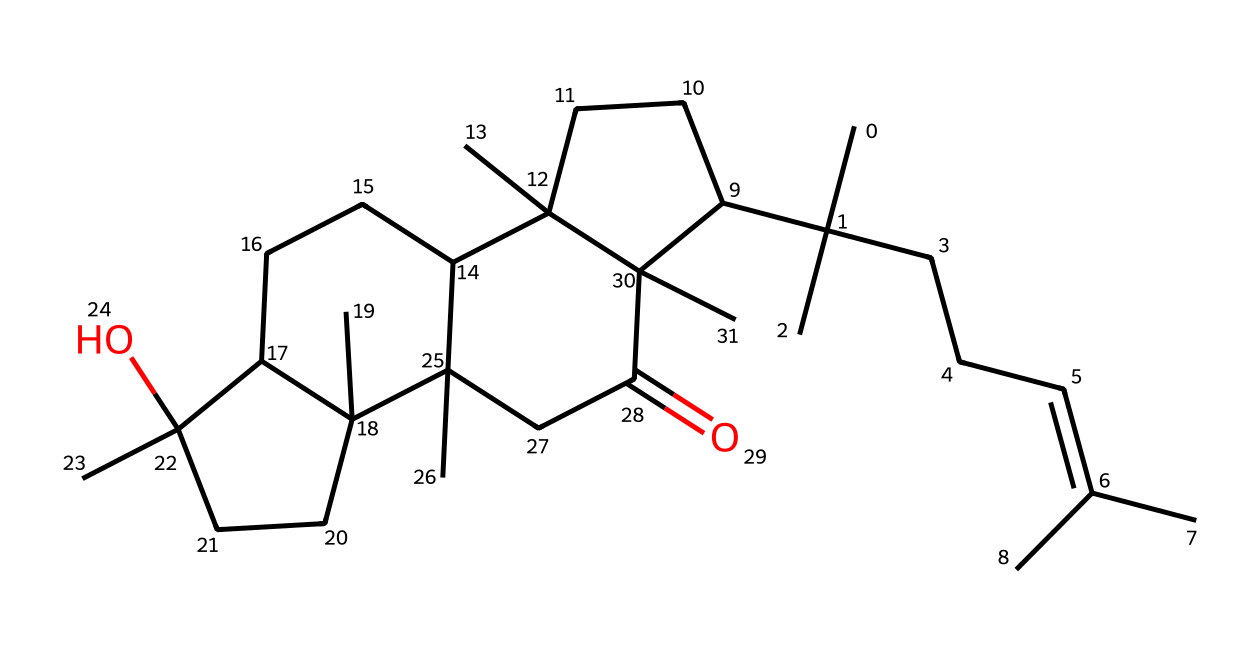What is the molecular formula of myrrh represented by this SMILES? To derive the molecular formula, count the carbon (C), hydrogen (H), and any other atoms in the SMILES representation. In this case, we find 30 carbon atoms and 50 hydrogen atoms, yielding a molecular formula of C30H50.
Answer: C30H50 How many rings are present in the structure of myrrh? Analyzing the structure, we can identify the number of cyclic formations or rings. The structure exhibits several interconnected cyclic features, particularly the fused ring systems. There are three distinct rings present.
Answer: 3 What functional group is present in myrrh? Evaluating the structure, particularly near the end of the chain, reveals a hydroxyl group (-OH) attached to one of the rings, indicating the presence of an alcohol functional group in myrrh.
Answer: alcohol What type of compound is myrrh? Myrrh is derived from resinous sources, and analyzing the structure shows it has a complex arrangement typical of terpenes or sesquiterpenes, common in aromatic resins, which categorizes it as a resin.
Answer: resin What is the total number of double bonds in the myrrh structure? By careful examination of the carbon-carbon connections in the structure, one can count the number of double bonds. In this case, there is one double bond present within the overall structure of myrrh.
Answer: 1 